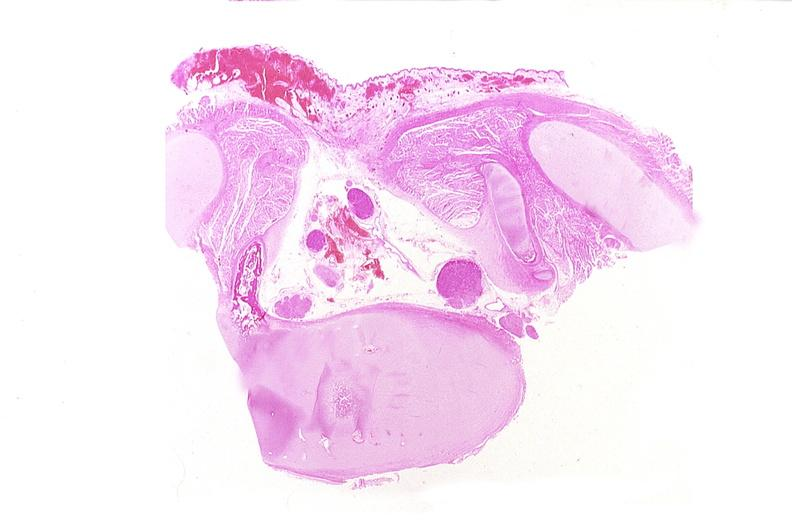does embryo-fetus show neural tube defect, meningomyelocele?
Answer the question using a single word or phrase. No 